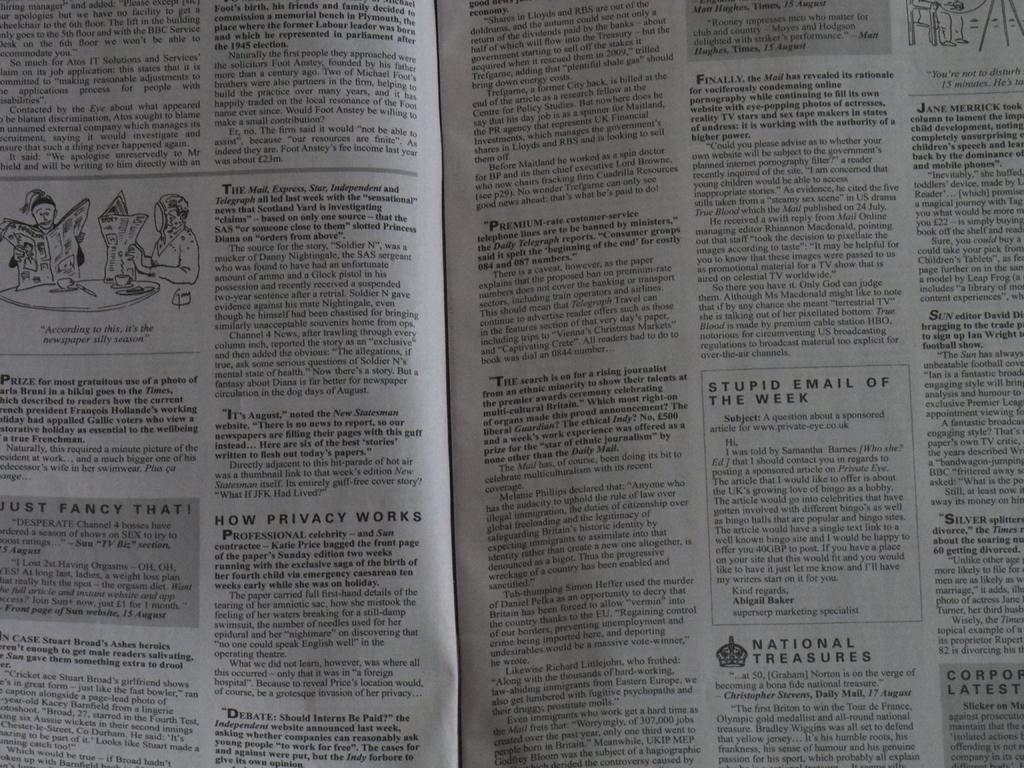What is the stupid e-mail of the week?
Offer a very short reply. A question about a sponsored article for www.private-eye.co.uk. What website is on stupid e-mail of the week?
Ensure brevity in your answer.  Www.private-eye.co.uk. 